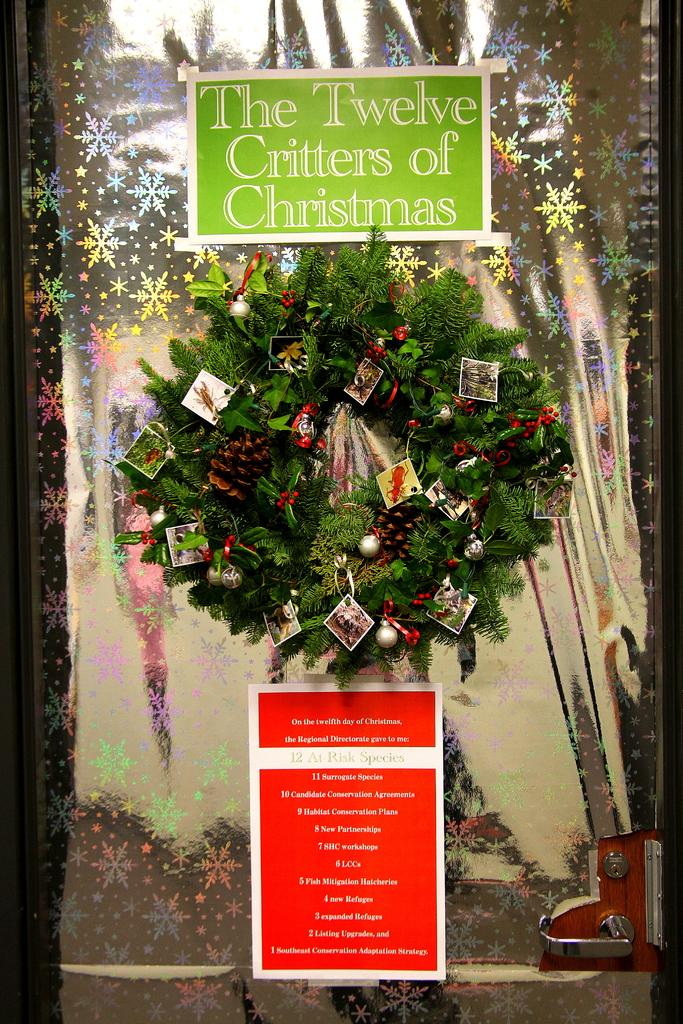What colors are the posters in the image? There is a red color poster and a green color poster in the image. What can be seen on the glass door in the image? Christmas decoration ornaments items are pasted on a glass door. Is there any coal visible in the image? No, there is no coal present in the image. Can you see any poisonous substances in the image? No, there are no poisonous substances visible in the image. 